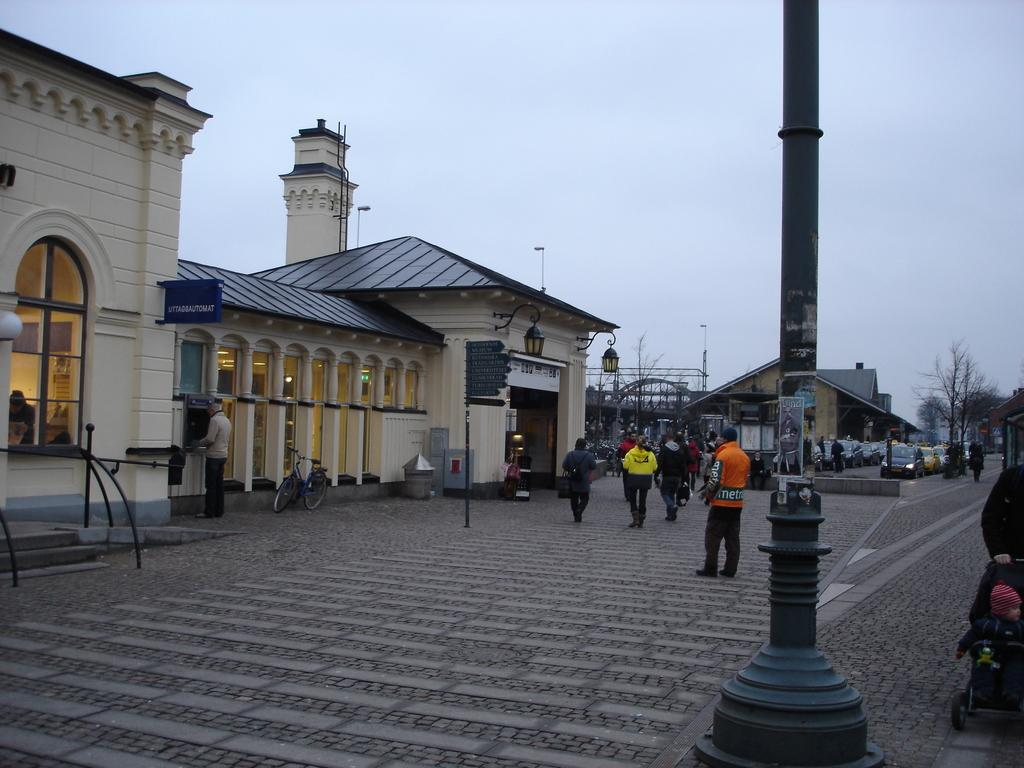What is happening on the road in the image? There are people and vehicles on the road in the image. What mode of transportation can be seen in the image? A bicycle is visible in the image. What type of structures are present in the image? There are buildings in the image. What type of vegetation is present in the image? Trees are present in the image. What type of illumination is present in the image? There are lights in the image. What other objects can be seen in the image? There are other objects in the image. What can be seen in the background of the image? The sky is visible in the background of the image. Where is the playground located in the image? There is no playground present in the image. What type of vest is being worn by the people in the image? There is no mention of a vest being worn by anyone in the image. 